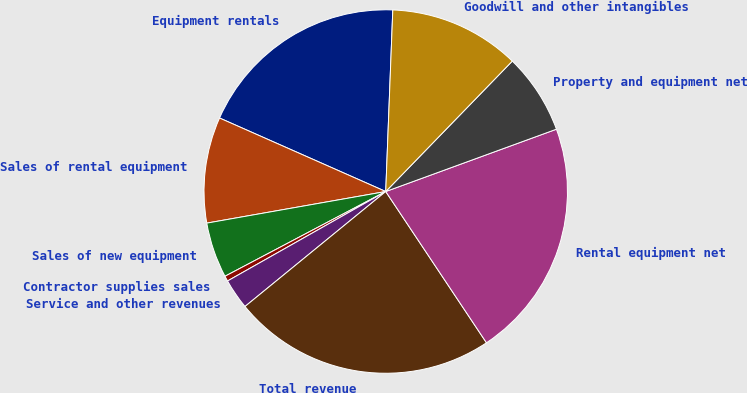<chart> <loc_0><loc_0><loc_500><loc_500><pie_chart><fcel>Equipment rentals<fcel>Sales of rental equipment<fcel>Sales of new equipment<fcel>Contractor supplies sales<fcel>Service and other revenues<fcel>Total revenue<fcel>Rental equipment net<fcel>Property and equipment net<fcel>Goodwill and other intangibles<nl><fcel>18.99%<fcel>9.41%<fcel>4.94%<fcel>0.47%<fcel>2.71%<fcel>23.45%<fcel>21.22%<fcel>7.17%<fcel>11.64%<nl></chart> 